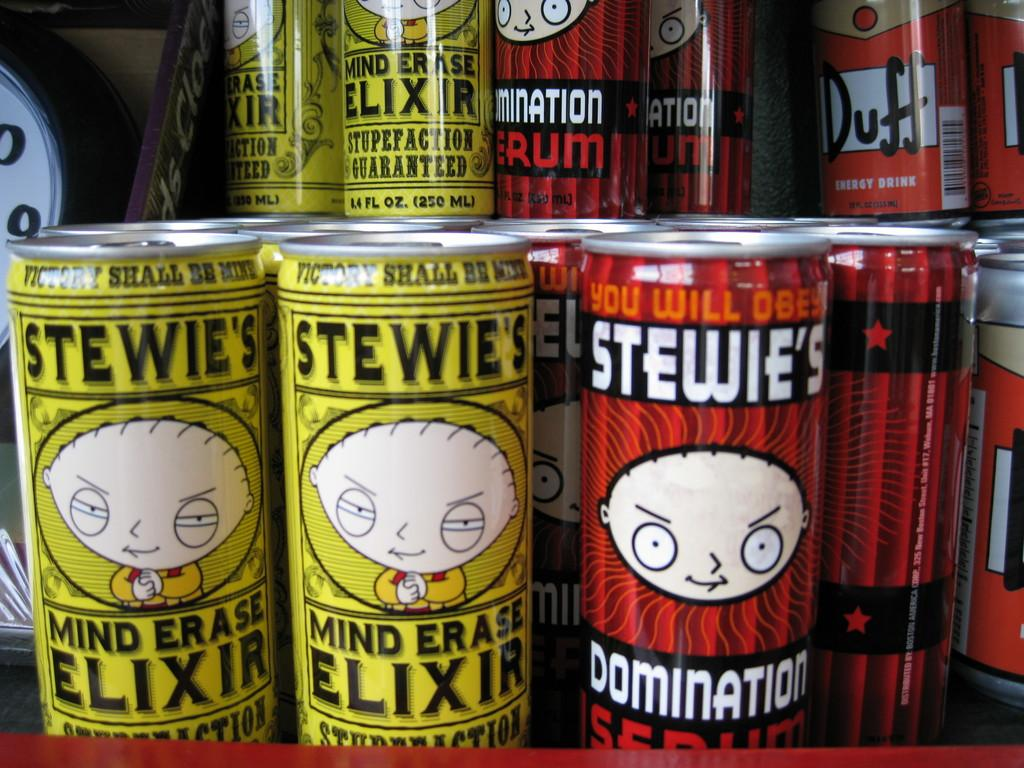<image>
Write a terse but informative summary of the picture. cans with stewie griffin on them that says 'stewies mind erase elixir 